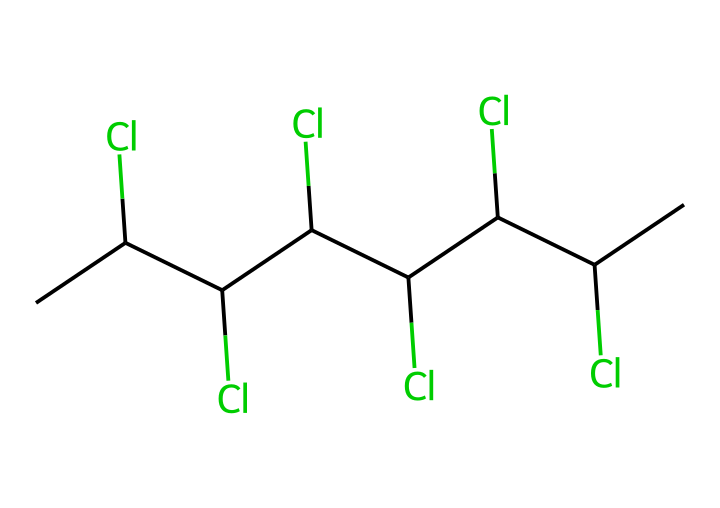What is the primary element present in the chemical? The SMILES representation shows several carbon atoms (C) and chlorine atoms (Cl), making carbon the primary element.
Answer: carbon How many chlorine atoms are in this chemical? By counting the 'Cl' notations in the SMILES, there are six chlorine atoms present in the structure.
Answer: six What type of plastic is indicated by this molecular structure? This structure corresponds to polyvinyl chloride (PVC), a common type of plastic known for its use in various applications.
Answer: polyvinyl chloride What chemical bonding is mainly present in this compound? The presence of carbon-carbon (C-C) and carbon-chlorine (C-Cl) bonds is evident throughout the chemical structure, indicating covalent bonding.
Answer: covalent Is this chemical composition potentially harmful to health? The presence of multiple chlorine atoms often raises concerns about toxicity and environmental impact, leading to the general perception that it can be harmful.
Answer: potentially harmful How many carbon atoms are included in this chemical structure? Counting the 'C' in the SMILES representation shows there are seven carbon atoms in total in the molecule.
Answer: seven 